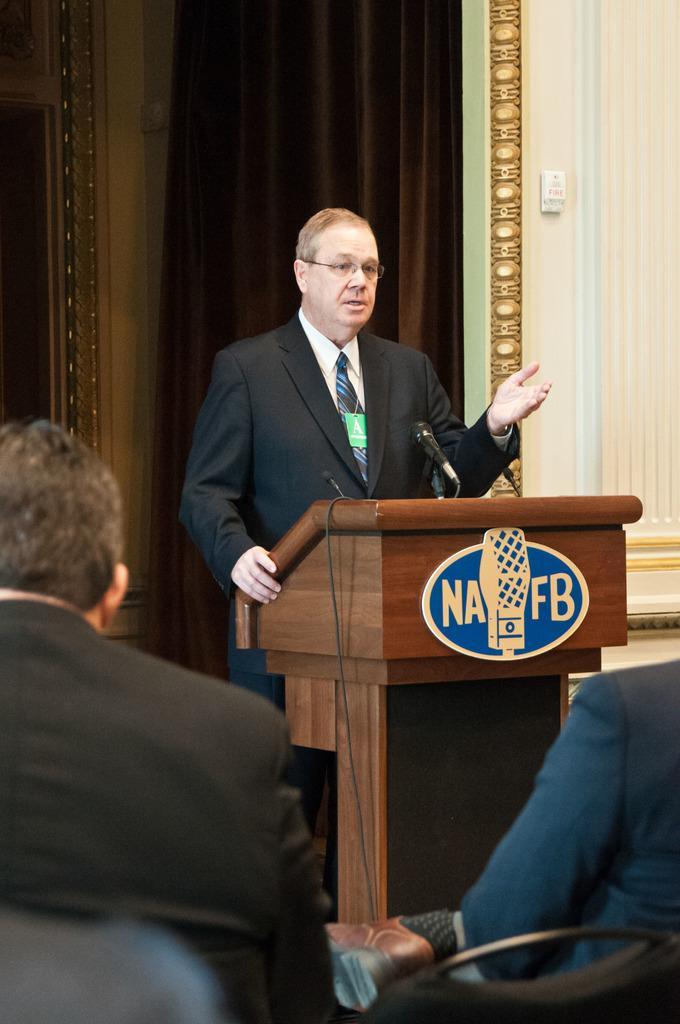How would you summarize this image in a sentence or two? In this image we can see a man is standing in front of a mike. Here we can see a podium and two persons are sitting on the chairs. In the background we can see wall and a curtain. 